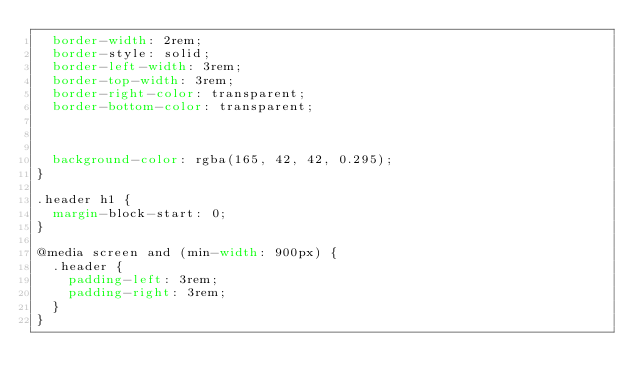Convert code to text. <code><loc_0><loc_0><loc_500><loc_500><_CSS_>	border-width: 2rem;
	border-style: solid;
	border-left-width: 3rem;
	border-top-width: 3rem;
	border-right-color: transparent;
	border-bottom-color: transparent;



	background-color: rgba(165, 42, 42, 0.295);
}

.header h1 {
	margin-block-start: 0;
}

@media screen and (min-width: 900px) {
	.header {
		padding-left: 3rem;
		padding-right: 3rem;
	}
}
</code> 